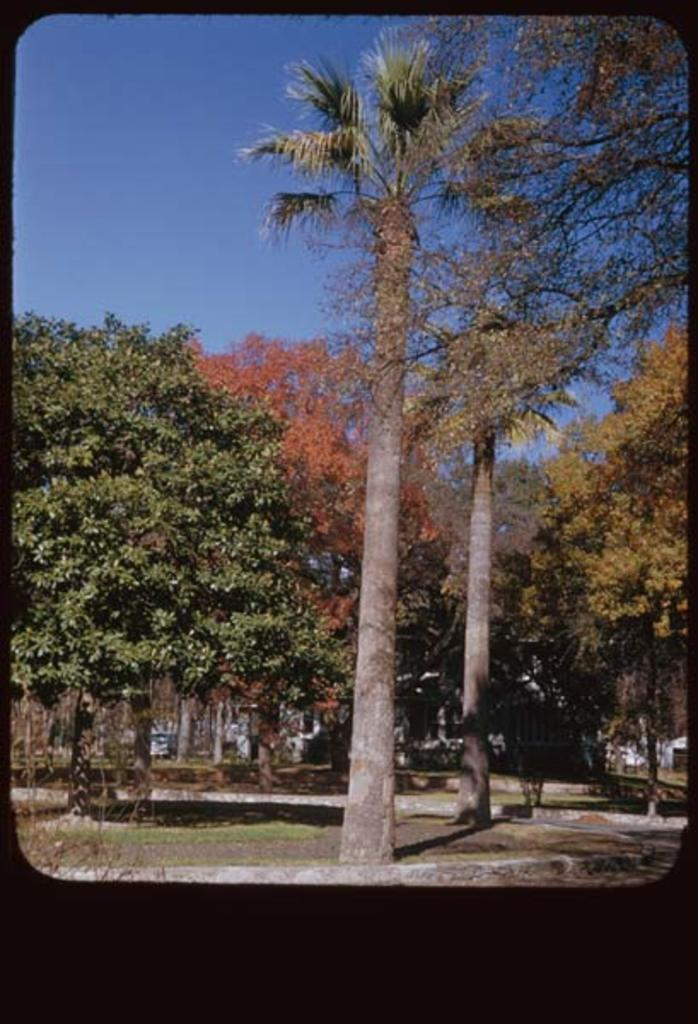Where might the image have been taken? The image might have been taken in a park. What type of vegetation can be seen in the image? There are many trees in the image. What is the ground surface like in the image? There is grass in the image. What else can be seen in the image besides trees and grass? There are other objects in the image. What is visible at the top of the image? The sky is visible at the top of the image. How many toes can be seen on the star in the image? There is no star or toes present in the image. What type of pencil is being used to draw the objects in the image? There is no pencil or drawing activity depicted in the image. 